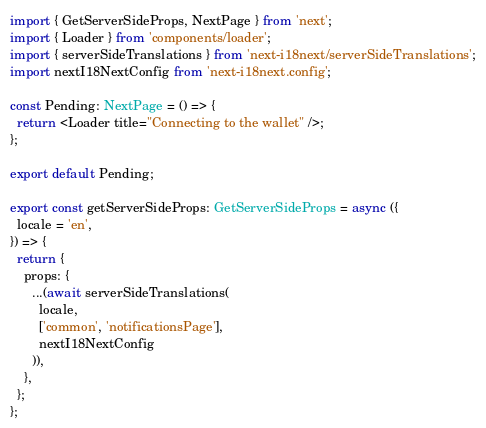<code> <loc_0><loc_0><loc_500><loc_500><_TypeScript_>import { GetServerSideProps, NextPage } from 'next';
import { Loader } from 'components/loader';
import { serverSideTranslations } from 'next-i18next/serverSideTranslations';
import nextI18NextConfig from 'next-i18next.config';

const Pending: NextPage = () => {
  return <Loader title="Connecting to the wallet" />;
};

export default Pending;

export const getServerSideProps: GetServerSideProps = async ({
  locale = 'en',
}) => {
  return {
    props: {
      ...(await serverSideTranslations(
        locale,
        ['common', 'notificationsPage'],
        nextI18NextConfig
      )),
    },
  };
};
</code> 